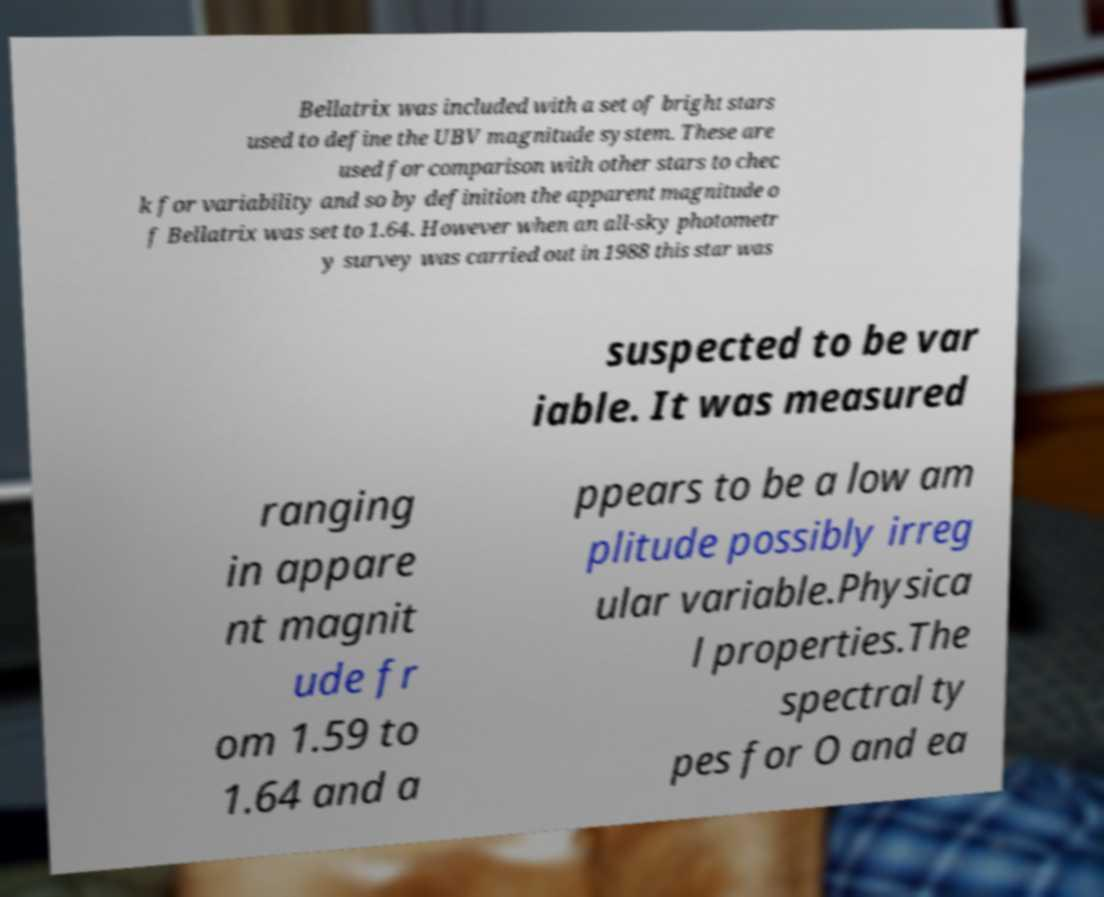Please read and relay the text visible in this image. What does it say? Bellatrix was included with a set of bright stars used to define the UBV magnitude system. These are used for comparison with other stars to chec k for variability and so by definition the apparent magnitude o f Bellatrix was set to 1.64. However when an all-sky photometr y survey was carried out in 1988 this star was suspected to be var iable. It was measured ranging in appare nt magnit ude fr om 1.59 to 1.64 and a ppears to be a low am plitude possibly irreg ular variable.Physica l properties.The spectral ty pes for O and ea 